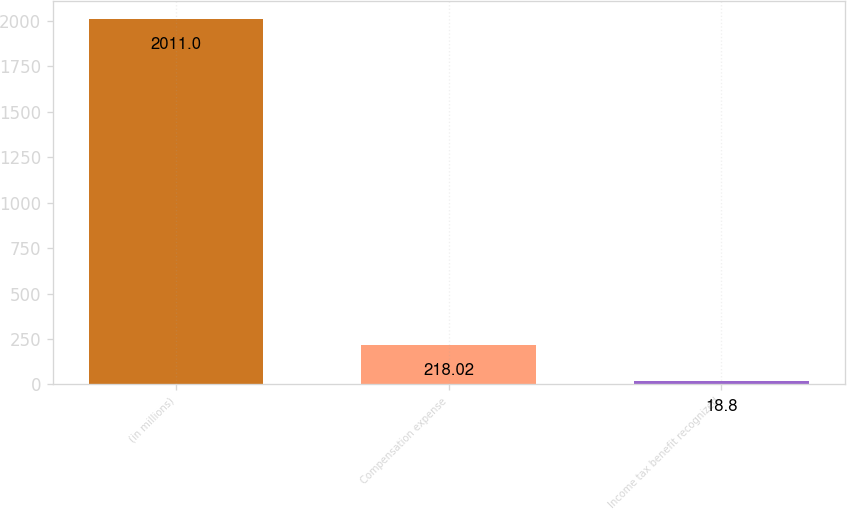<chart> <loc_0><loc_0><loc_500><loc_500><bar_chart><fcel>(in millions)<fcel>Compensation expense<fcel>Income tax benefit recognized<nl><fcel>2011<fcel>218.02<fcel>18.8<nl></chart> 